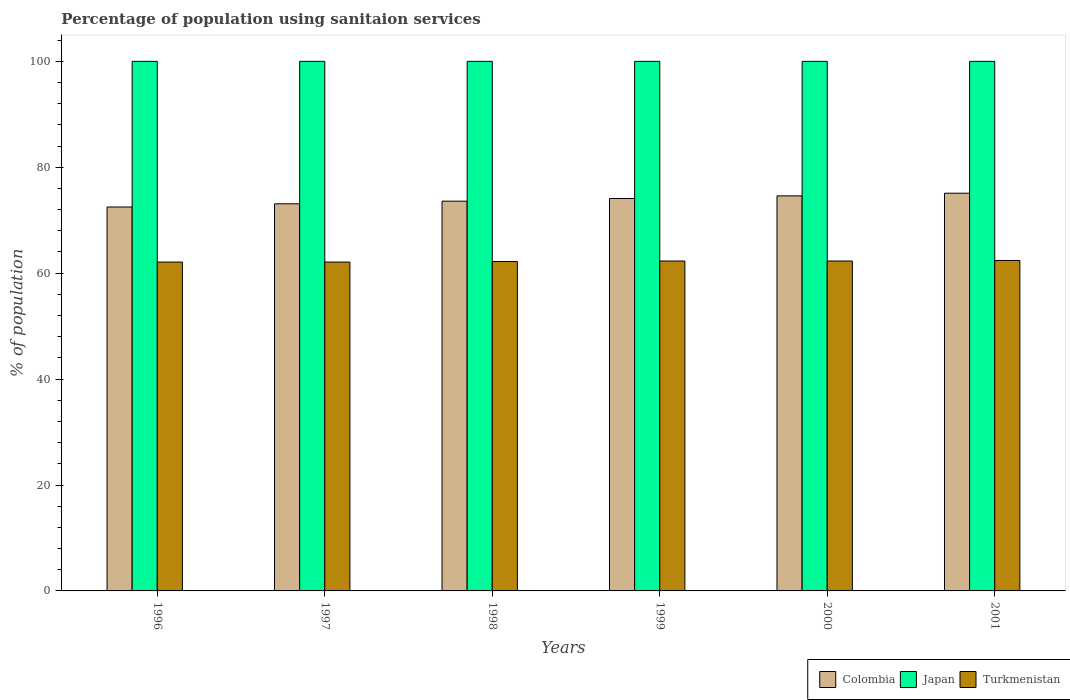How many different coloured bars are there?
Your response must be concise. 3. How many groups of bars are there?
Make the answer very short. 6. Are the number of bars per tick equal to the number of legend labels?
Your answer should be very brief. Yes. Are the number of bars on each tick of the X-axis equal?
Your answer should be very brief. Yes. How many bars are there on the 5th tick from the right?
Offer a very short reply. 3. What is the label of the 1st group of bars from the left?
Your answer should be compact. 1996. In how many cases, is the number of bars for a given year not equal to the number of legend labels?
Your answer should be compact. 0. What is the percentage of population using sanitaion services in Turkmenistan in 2000?
Offer a terse response. 62.3. Across all years, what is the maximum percentage of population using sanitaion services in Colombia?
Your answer should be compact. 75.1. Across all years, what is the minimum percentage of population using sanitaion services in Turkmenistan?
Your answer should be very brief. 62.1. What is the total percentage of population using sanitaion services in Japan in the graph?
Offer a terse response. 600. What is the difference between the percentage of population using sanitaion services in Turkmenistan in 1997 and the percentage of population using sanitaion services in Colombia in 1996?
Your answer should be compact. -10.4. What is the average percentage of population using sanitaion services in Colombia per year?
Provide a short and direct response. 73.83. In the year 1997, what is the difference between the percentage of population using sanitaion services in Turkmenistan and percentage of population using sanitaion services in Japan?
Offer a very short reply. -37.9. What is the ratio of the percentage of population using sanitaion services in Turkmenistan in 1996 to that in 2001?
Your answer should be very brief. 1. Is the percentage of population using sanitaion services in Japan in 1997 less than that in 1998?
Your answer should be compact. No. Is the difference between the percentage of population using sanitaion services in Turkmenistan in 1999 and 2001 greater than the difference between the percentage of population using sanitaion services in Japan in 1999 and 2001?
Your answer should be very brief. No. What is the difference between the highest and the second highest percentage of population using sanitaion services in Turkmenistan?
Your answer should be very brief. 0.1. In how many years, is the percentage of population using sanitaion services in Japan greater than the average percentage of population using sanitaion services in Japan taken over all years?
Give a very brief answer. 0. Is the sum of the percentage of population using sanitaion services in Colombia in 1997 and 1998 greater than the maximum percentage of population using sanitaion services in Japan across all years?
Give a very brief answer. Yes. What does the 3rd bar from the left in 1996 represents?
Your answer should be very brief. Turkmenistan. Is it the case that in every year, the sum of the percentage of population using sanitaion services in Japan and percentage of population using sanitaion services in Turkmenistan is greater than the percentage of population using sanitaion services in Colombia?
Your answer should be compact. Yes. Are all the bars in the graph horizontal?
Give a very brief answer. No. Are the values on the major ticks of Y-axis written in scientific E-notation?
Your response must be concise. No. Does the graph contain grids?
Offer a terse response. No. How are the legend labels stacked?
Keep it short and to the point. Horizontal. What is the title of the graph?
Keep it short and to the point. Percentage of population using sanitaion services. Does "Puerto Rico" appear as one of the legend labels in the graph?
Offer a very short reply. No. What is the label or title of the Y-axis?
Your answer should be very brief. % of population. What is the % of population in Colombia in 1996?
Offer a terse response. 72.5. What is the % of population in Japan in 1996?
Your answer should be compact. 100. What is the % of population in Turkmenistan in 1996?
Provide a short and direct response. 62.1. What is the % of population in Colombia in 1997?
Ensure brevity in your answer.  73.1. What is the % of population of Turkmenistan in 1997?
Make the answer very short. 62.1. What is the % of population in Colombia in 1998?
Ensure brevity in your answer.  73.6. What is the % of population in Japan in 1998?
Keep it short and to the point. 100. What is the % of population of Turkmenistan in 1998?
Offer a terse response. 62.2. What is the % of population in Colombia in 1999?
Ensure brevity in your answer.  74.1. What is the % of population in Turkmenistan in 1999?
Provide a succinct answer. 62.3. What is the % of population in Colombia in 2000?
Keep it short and to the point. 74.6. What is the % of population of Turkmenistan in 2000?
Offer a terse response. 62.3. What is the % of population of Colombia in 2001?
Your response must be concise. 75.1. What is the % of population in Turkmenistan in 2001?
Give a very brief answer. 62.4. Across all years, what is the maximum % of population of Colombia?
Keep it short and to the point. 75.1. Across all years, what is the maximum % of population in Japan?
Give a very brief answer. 100. Across all years, what is the maximum % of population of Turkmenistan?
Offer a terse response. 62.4. Across all years, what is the minimum % of population of Colombia?
Your answer should be compact. 72.5. Across all years, what is the minimum % of population of Japan?
Provide a short and direct response. 100. Across all years, what is the minimum % of population of Turkmenistan?
Make the answer very short. 62.1. What is the total % of population of Colombia in the graph?
Offer a very short reply. 443. What is the total % of population of Japan in the graph?
Provide a succinct answer. 600. What is the total % of population in Turkmenistan in the graph?
Make the answer very short. 373.4. What is the difference between the % of population of Colombia in 1996 and that in 1997?
Your answer should be compact. -0.6. What is the difference between the % of population of Colombia in 1996 and that in 1998?
Give a very brief answer. -1.1. What is the difference between the % of population of Japan in 1996 and that in 1998?
Your response must be concise. 0. What is the difference between the % of population of Colombia in 1996 and that in 1999?
Keep it short and to the point. -1.6. What is the difference between the % of population in Colombia in 1996 and that in 2000?
Keep it short and to the point. -2.1. What is the difference between the % of population of Turkmenistan in 1996 and that in 2000?
Your answer should be very brief. -0.2. What is the difference between the % of population of Colombia in 1996 and that in 2001?
Your answer should be very brief. -2.6. What is the difference between the % of population of Japan in 1996 and that in 2001?
Provide a succinct answer. 0. What is the difference between the % of population of Colombia in 1997 and that in 1998?
Your answer should be compact. -0.5. What is the difference between the % of population of Japan in 1997 and that in 1998?
Offer a terse response. 0. What is the difference between the % of population in Colombia in 1997 and that in 1999?
Your answer should be very brief. -1. What is the difference between the % of population of Japan in 1997 and that in 1999?
Offer a terse response. 0. What is the difference between the % of population of Turkmenistan in 1997 and that in 1999?
Provide a succinct answer. -0.2. What is the difference between the % of population of Colombia in 1997 and that in 2000?
Your answer should be compact. -1.5. What is the difference between the % of population in Turkmenistan in 1997 and that in 2000?
Provide a short and direct response. -0.2. What is the difference between the % of population in Turkmenistan in 1997 and that in 2001?
Your response must be concise. -0.3. What is the difference between the % of population of Colombia in 1998 and that in 1999?
Provide a succinct answer. -0.5. What is the difference between the % of population of Turkmenistan in 1998 and that in 1999?
Provide a succinct answer. -0.1. What is the difference between the % of population of Japan in 1998 and that in 2000?
Make the answer very short. 0. What is the difference between the % of population of Turkmenistan in 1998 and that in 2001?
Keep it short and to the point. -0.2. What is the difference between the % of population of Colombia in 1999 and that in 2000?
Provide a succinct answer. -0.5. What is the difference between the % of population of Turkmenistan in 1999 and that in 2001?
Provide a succinct answer. -0.1. What is the difference between the % of population in Japan in 2000 and that in 2001?
Offer a very short reply. 0. What is the difference between the % of population of Turkmenistan in 2000 and that in 2001?
Provide a short and direct response. -0.1. What is the difference between the % of population of Colombia in 1996 and the % of population of Japan in 1997?
Keep it short and to the point. -27.5. What is the difference between the % of population in Japan in 1996 and the % of population in Turkmenistan in 1997?
Ensure brevity in your answer.  37.9. What is the difference between the % of population in Colombia in 1996 and the % of population in Japan in 1998?
Keep it short and to the point. -27.5. What is the difference between the % of population of Japan in 1996 and the % of population of Turkmenistan in 1998?
Offer a very short reply. 37.8. What is the difference between the % of population of Colombia in 1996 and the % of population of Japan in 1999?
Ensure brevity in your answer.  -27.5. What is the difference between the % of population of Colombia in 1996 and the % of population of Turkmenistan in 1999?
Make the answer very short. 10.2. What is the difference between the % of population in Japan in 1996 and the % of population in Turkmenistan in 1999?
Offer a terse response. 37.7. What is the difference between the % of population in Colombia in 1996 and the % of population in Japan in 2000?
Provide a succinct answer. -27.5. What is the difference between the % of population in Japan in 1996 and the % of population in Turkmenistan in 2000?
Make the answer very short. 37.7. What is the difference between the % of population in Colombia in 1996 and the % of population in Japan in 2001?
Give a very brief answer. -27.5. What is the difference between the % of population in Japan in 1996 and the % of population in Turkmenistan in 2001?
Your answer should be compact. 37.6. What is the difference between the % of population of Colombia in 1997 and the % of population of Japan in 1998?
Keep it short and to the point. -26.9. What is the difference between the % of population of Japan in 1997 and the % of population of Turkmenistan in 1998?
Your response must be concise. 37.8. What is the difference between the % of population of Colombia in 1997 and the % of population of Japan in 1999?
Ensure brevity in your answer.  -26.9. What is the difference between the % of population in Japan in 1997 and the % of population in Turkmenistan in 1999?
Make the answer very short. 37.7. What is the difference between the % of population of Colombia in 1997 and the % of population of Japan in 2000?
Provide a succinct answer. -26.9. What is the difference between the % of population in Japan in 1997 and the % of population in Turkmenistan in 2000?
Your response must be concise. 37.7. What is the difference between the % of population of Colombia in 1997 and the % of population of Japan in 2001?
Offer a terse response. -26.9. What is the difference between the % of population of Colombia in 1997 and the % of population of Turkmenistan in 2001?
Make the answer very short. 10.7. What is the difference between the % of population of Japan in 1997 and the % of population of Turkmenistan in 2001?
Give a very brief answer. 37.6. What is the difference between the % of population of Colombia in 1998 and the % of population of Japan in 1999?
Make the answer very short. -26.4. What is the difference between the % of population in Japan in 1998 and the % of population in Turkmenistan in 1999?
Give a very brief answer. 37.7. What is the difference between the % of population of Colombia in 1998 and the % of population of Japan in 2000?
Offer a terse response. -26.4. What is the difference between the % of population of Colombia in 1998 and the % of population of Turkmenistan in 2000?
Provide a short and direct response. 11.3. What is the difference between the % of population in Japan in 1998 and the % of population in Turkmenistan in 2000?
Your answer should be compact. 37.7. What is the difference between the % of population in Colombia in 1998 and the % of population in Japan in 2001?
Offer a terse response. -26.4. What is the difference between the % of population in Japan in 1998 and the % of population in Turkmenistan in 2001?
Ensure brevity in your answer.  37.6. What is the difference between the % of population in Colombia in 1999 and the % of population in Japan in 2000?
Give a very brief answer. -25.9. What is the difference between the % of population in Japan in 1999 and the % of population in Turkmenistan in 2000?
Your response must be concise. 37.7. What is the difference between the % of population of Colombia in 1999 and the % of population of Japan in 2001?
Keep it short and to the point. -25.9. What is the difference between the % of population in Japan in 1999 and the % of population in Turkmenistan in 2001?
Your answer should be very brief. 37.6. What is the difference between the % of population in Colombia in 2000 and the % of population in Japan in 2001?
Provide a short and direct response. -25.4. What is the difference between the % of population in Colombia in 2000 and the % of population in Turkmenistan in 2001?
Keep it short and to the point. 12.2. What is the difference between the % of population in Japan in 2000 and the % of population in Turkmenistan in 2001?
Make the answer very short. 37.6. What is the average % of population of Colombia per year?
Your answer should be compact. 73.83. What is the average % of population in Turkmenistan per year?
Make the answer very short. 62.23. In the year 1996, what is the difference between the % of population in Colombia and % of population in Japan?
Ensure brevity in your answer.  -27.5. In the year 1996, what is the difference between the % of population of Colombia and % of population of Turkmenistan?
Give a very brief answer. 10.4. In the year 1996, what is the difference between the % of population in Japan and % of population in Turkmenistan?
Give a very brief answer. 37.9. In the year 1997, what is the difference between the % of population in Colombia and % of population in Japan?
Your response must be concise. -26.9. In the year 1997, what is the difference between the % of population in Japan and % of population in Turkmenistan?
Your response must be concise. 37.9. In the year 1998, what is the difference between the % of population of Colombia and % of population of Japan?
Offer a very short reply. -26.4. In the year 1998, what is the difference between the % of population in Colombia and % of population in Turkmenistan?
Your response must be concise. 11.4. In the year 1998, what is the difference between the % of population of Japan and % of population of Turkmenistan?
Offer a terse response. 37.8. In the year 1999, what is the difference between the % of population in Colombia and % of population in Japan?
Make the answer very short. -25.9. In the year 1999, what is the difference between the % of population in Colombia and % of population in Turkmenistan?
Your response must be concise. 11.8. In the year 1999, what is the difference between the % of population of Japan and % of population of Turkmenistan?
Give a very brief answer. 37.7. In the year 2000, what is the difference between the % of population of Colombia and % of population of Japan?
Ensure brevity in your answer.  -25.4. In the year 2000, what is the difference between the % of population of Japan and % of population of Turkmenistan?
Your answer should be very brief. 37.7. In the year 2001, what is the difference between the % of population in Colombia and % of population in Japan?
Your response must be concise. -24.9. In the year 2001, what is the difference between the % of population in Japan and % of population in Turkmenistan?
Your answer should be very brief. 37.6. What is the ratio of the % of population in Colombia in 1996 to that in 1998?
Your answer should be very brief. 0.99. What is the ratio of the % of population of Japan in 1996 to that in 1998?
Your answer should be very brief. 1. What is the ratio of the % of population in Colombia in 1996 to that in 1999?
Give a very brief answer. 0.98. What is the ratio of the % of population in Japan in 1996 to that in 1999?
Make the answer very short. 1. What is the ratio of the % of population of Colombia in 1996 to that in 2000?
Offer a terse response. 0.97. What is the ratio of the % of population of Japan in 1996 to that in 2000?
Provide a succinct answer. 1. What is the ratio of the % of population in Turkmenistan in 1996 to that in 2000?
Your answer should be compact. 1. What is the ratio of the % of population of Colombia in 1996 to that in 2001?
Keep it short and to the point. 0.97. What is the ratio of the % of population in Turkmenistan in 1996 to that in 2001?
Provide a succinct answer. 1. What is the ratio of the % of population in Turkmenistan in 1997 to that in 1998?
Offer a terse response. 1. What is the ratio of the % of population in Colombia in 1997 to that in 1999?
Give a very brief answer. 0.99. What is the ratio of the % of population of Japan in 1997 to that in 1999?
Make the answer very short. 1. What is the ratio of the % of population in Colombia in 1997 to that in 2000?
Provide a short and direct response. 0.98. What is the ratio of the % of population in Japan in 1997 to that in 2000?
Your response must be concise. 1. What is the ratio of the % of population of Colombia in 1997 to that in 2001?
Offer a terse response. 0.97. What is the ratio of the % of population of Colombia in 1998 to that in 1999?
Make the answer very short. 0.99. What is the ratio of the % of population of Japan in 1998 to that in 1999?
Make the answer very short. 1. What is the ratio of the % of population of Colombia in 1998 to that in 2000?
Provide a succinct answer. 0.99. What is the ratio of the % of population of Japan in 1998 to that in 2000?
Ensure brevity in your answer.  1. What is the ratio of the % of population in Colombia in 1998 to that in 2001?
Ensure brevity in your answer.  0.98. What is the ratio of the % of population in Japan in 1998 to that in 2001?
Your answer should be very brief. 1. What is the ratio of the % of population in Colombia in 1999 to that in 2000?
Offer a terse response. 0.99. What is the ratio of the % of population in Colombia in 1999 to that in 2001?
Give a very brief answer. 0.99. What is the ratio of the % of population of Japan in 1999 to that in 2001?
Offer a terse response. 1. What is the ratio of the % of population in Colombia in 2000 to that in 2001?
Ensure brevity in your answer.  0.99. What is the ratio of the % of population in Japan in 2000 to that in 2001?
Provide a succinct answer. 1. What is the ratio of the % of population of Turkmenistan in 2000 to that in 2001?
Provide a succinct answer. 1. What is the difference between the highest and the lowest % of population of Colombia?
Provide a short and direct response. 2.6. What is the difference between the highest and the lowest % of population in Turkmenistan?
Your answer should be compact. 0.3. 